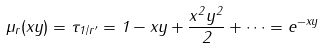Convert formula to latex. <formula><loc_0><loc_0><loc_500><loc_500>\mu _ { r } ( x y ) = \tau _ { 1 / { r ^ { \prime } } } = 1 - x y + \frac { x ^ { 2 } y ^ { 2 } } { 2 } + \cdots = e ^ { - x y }</formula> 